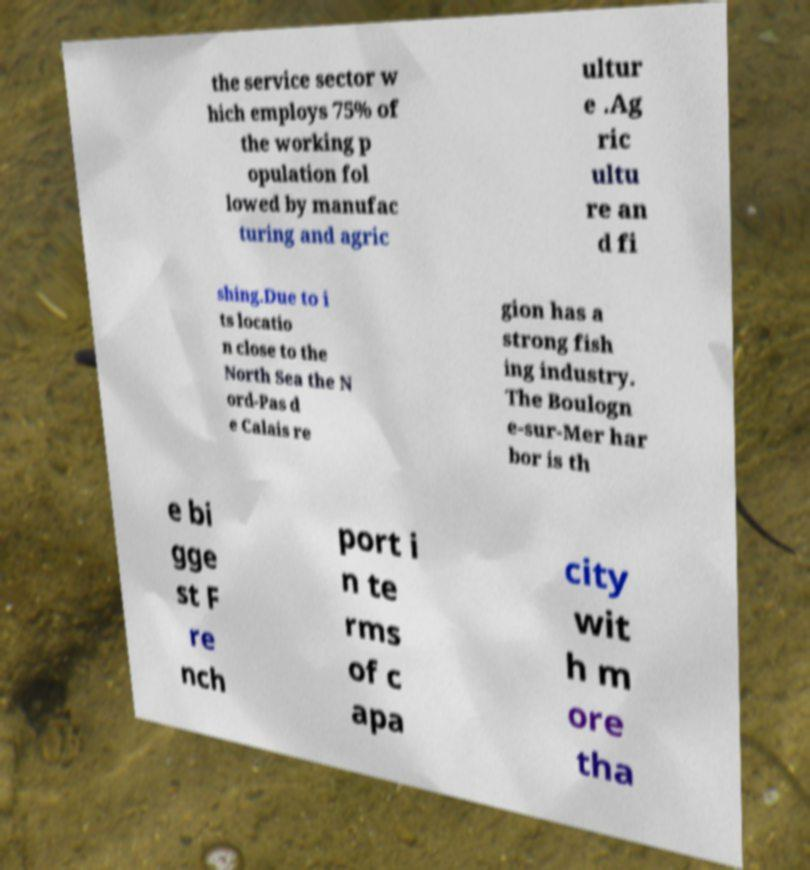What messages or text are displayed in this image? I need them in a readable, typed format. the service sector w hich employs 75% of the working p opulation fol lowed by manufac turing and agric ultur e .Ag ric ultu re an d fi shing.Due to i ts locatio n close to the North Sea the N ord-Pas d e Calais re gion has a strong fish ing industry. The Boulogn e-sur-Mer har bor is th e bi gge st F re nch port i n te rms of c apa city wit h m ore tha 